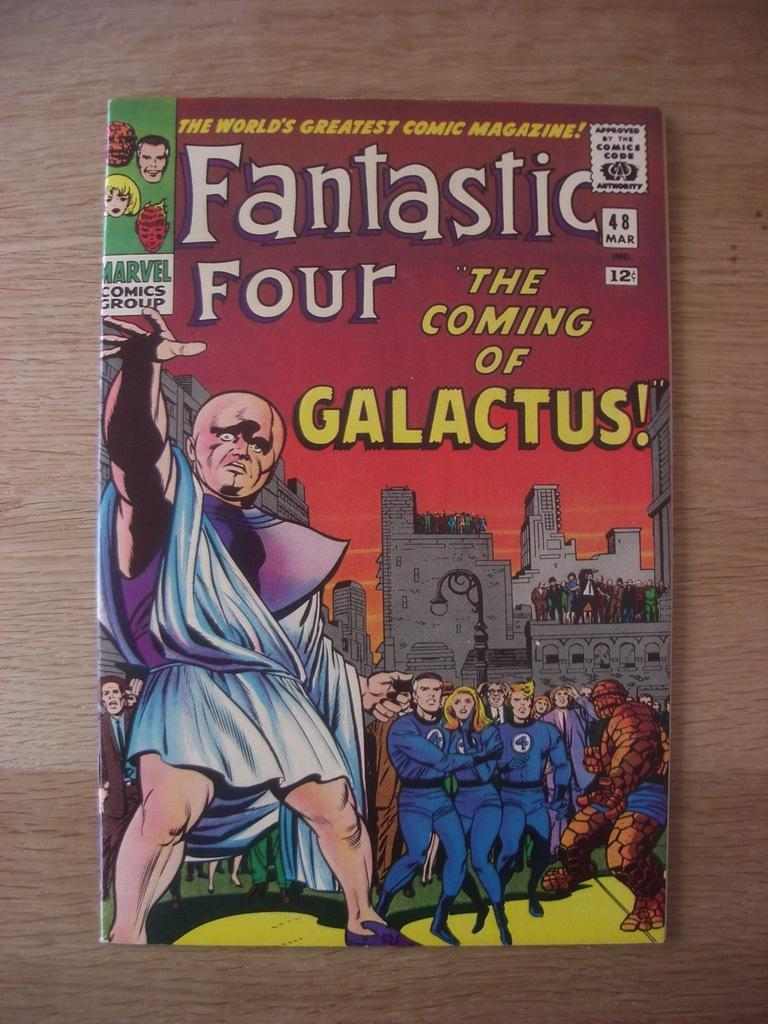<image>
Offer a succinct explanation of the picture presented. A Fantastic Four comic sits on top of a wooden surface 